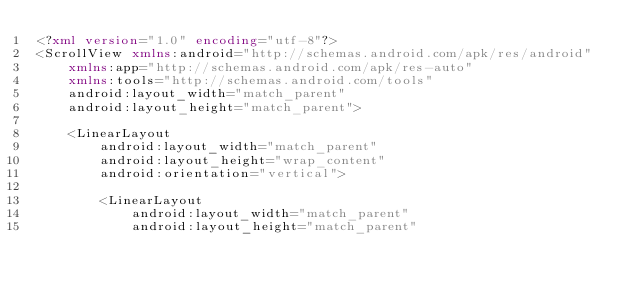<code> <loc_0><loc_0><loc_500><loc_500><_XML_><?xml version="1.0" encoding="utf-8"?>
<ScrollView xmlns:android="http://schemas.android.com/apk/res/android"
    xmlns:app="http://schemas.android.com/apk/res-auto"
    xmlns:tools="http://schemas.android.com/tools"
    android:layout_width="match_parent"
    android:layout_height="match_parent">

    <LinearLayout
        android:layout_width="match_parent"
        android:layout_height="wrap_content"
        android:orientation="vertical">

        <LinearLayout
            android:layout_width="match_parent"
            android:layout_height="match_parent"</code> 